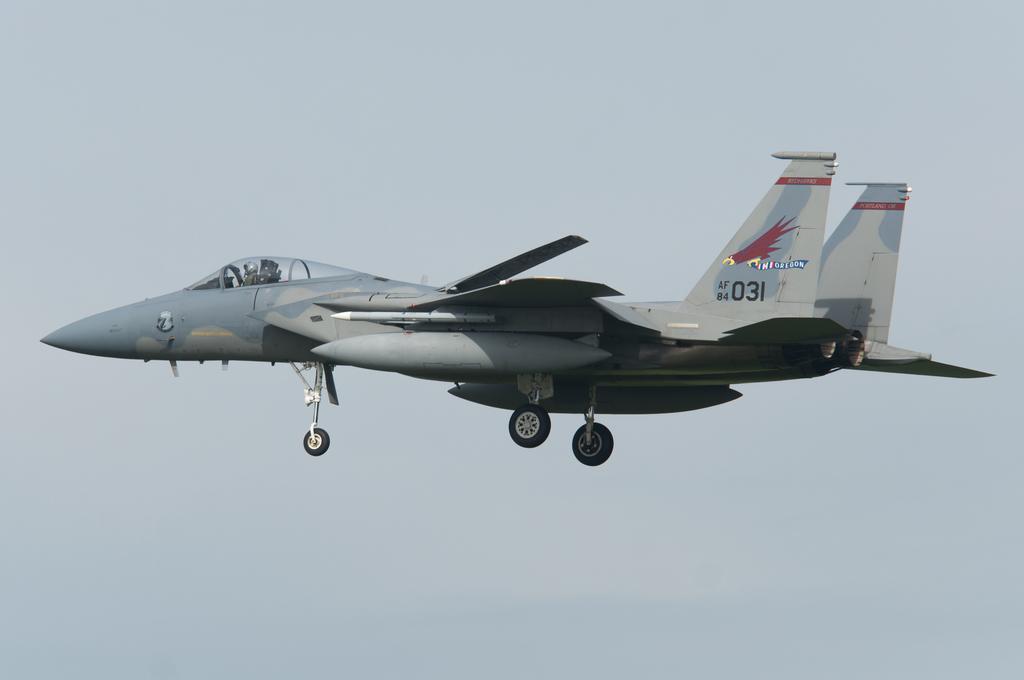What is the number on the tail wing?
Offer a very short reply. 031. 